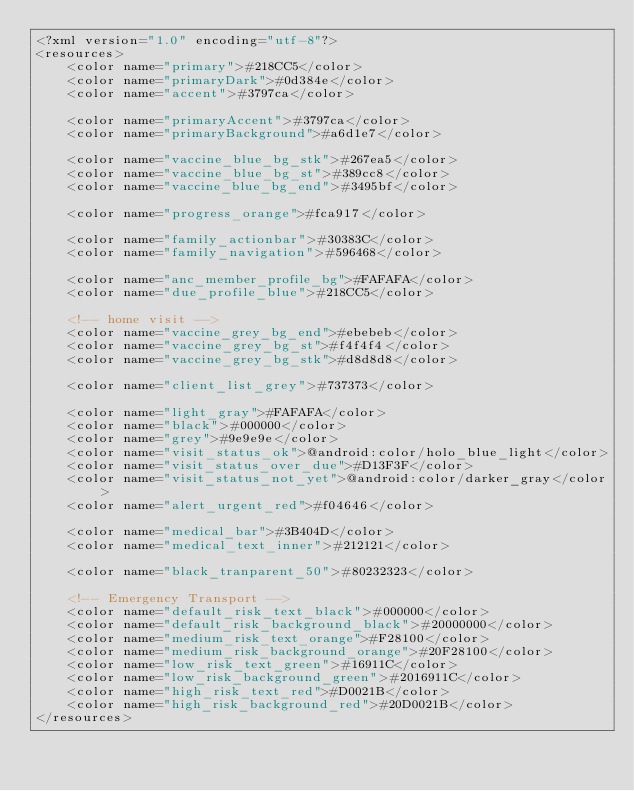<code> <loc_0><loc_0><loc_500><loc_500><_XML_><?xml version="1.0" encoding="utf-8"?>
<resources>
    <color name="primary">#218CC5</color>
    <color name="primaryDark">#0d384e</color>
    <color name="accent">#3797ca</color>

    <color name="primaryAccent">#3797ca</color>
    <color name="primaryBackground">#a6d1e7</color>

    <color name="vaccine_blue_bg_stk">#267ea5</color>
    <color name="vaccine_blue_bg_st">#389cc8</color>
    <color name="vaccine_blue_bg_end">#3495bf</color>

    <color name="progress_orange">#fca917</color>

    <color name="family_actionbar">#30383C</color>
    <color name="family_navigation">#596468</color>

    <color name="anc_member_profile_bg">#FAFAFA</color>
    <color name="due_profile_blue">#218CC5</color>

    <!-- home visit -->
    <color name="vaccine_grey_bg_end">#ebebeb</color>
    <color name="vaccine_grey_bg_st">#f4f4f4</color>
    <color name="vaccine_grey_bg_stk">#d8d8d8</color>

    <color name="client_list_grey">#737373</color>

    <color name="light_gray">#FAFAFA</color>
    <color name="black">#000000</color>
    <color name="grey">#9e9e9e</color>
    <color name="visit_status_ok">@android:color/holo_blue_light</color>
    <color name="visit_status_over_due">#D13F3F</color>
    <color name="visit_status_not_yet">@android:color/darker_gray</color>
    <color name="alert_urgent_red">#f04646</color>

    <color name="medical_bar">#3B404D</color>
    <color name="medical_text_inner">#212121</color>

    <color name="black_tranparent_50">#80232323</color>

    <!-- Emergency Transport -->
    <color name="default_risk_text_black">#000000</color>
    <color name="default_risk_background_black">#20000000</color>
    <color name="medium_risk_text_orange">#F28100</color>
    <color name="medium_risk_background_orange">#20F28100</color>
    <color name="low_risk_text_green">#16911C</color>
    <color name="low_risk_background_green">#2016911C</color>
    <color name="high_risk_text_red">#D0021B</color>
    <color name="high_risk_background_red">#20D0021B</color>
</resources></code> 